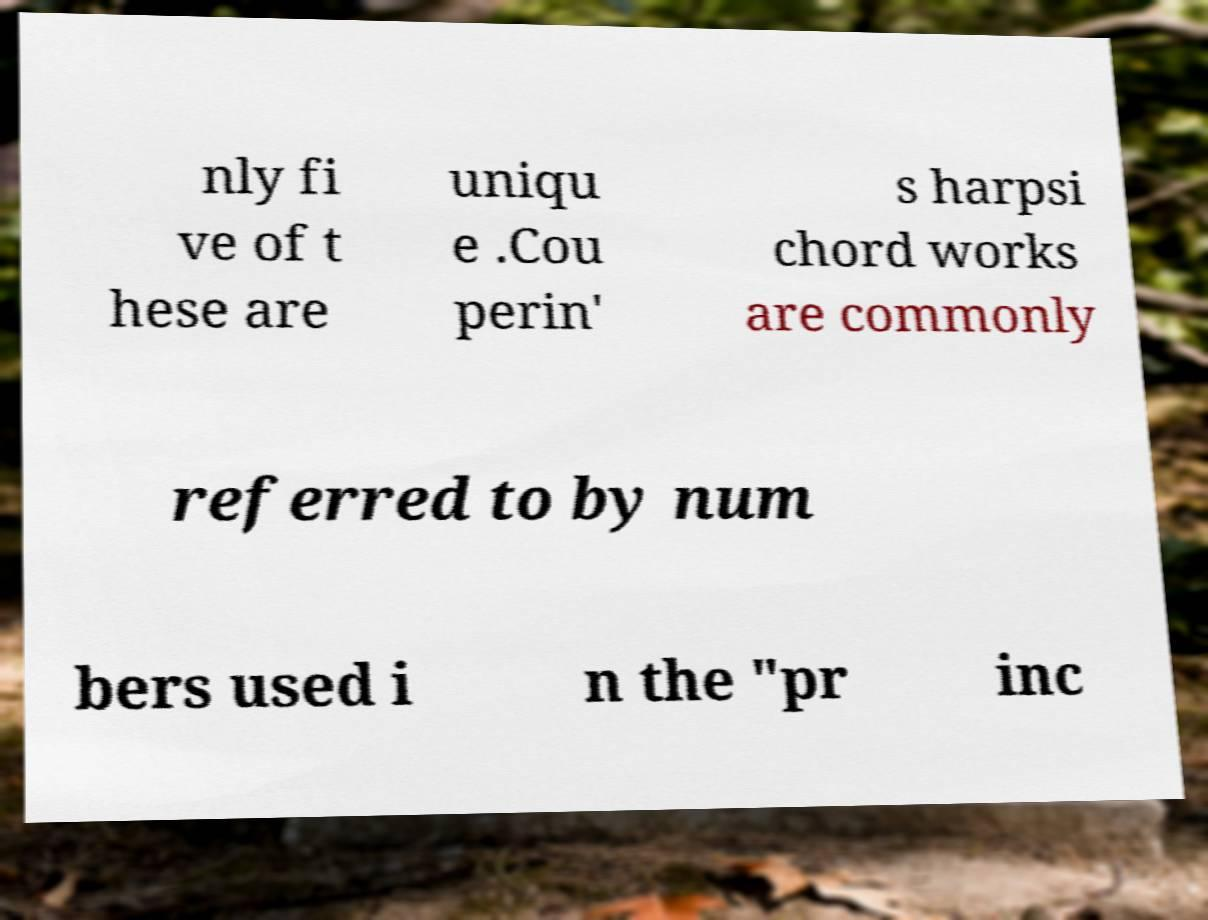Please identify and transcribe the text found in this image. nly fi ve of t hese are uniqu e .Cou perin' s harpsi chord works are commonly referred to by num bers used i n the "pr inc 